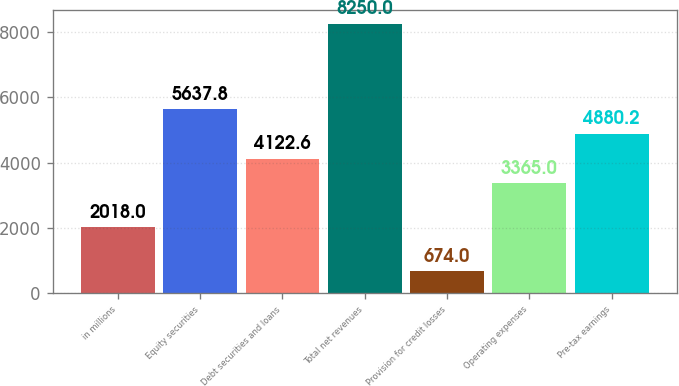Convert chart to OTSL. <chart><loc_0><loc_0><loc_500><loc_500><bar_chart><fcel>in millions<fcel>Equity securities<fcel>Debt securities and loans<fcel>Total net revenues<fcel>Provision for credit losses<fcel>Operating expenses<fcel>Pre-tax earnings<nl><fcel>2018<fcel>5637.8<fcel>4122.6<fcel>8250<fcel>674<fcel>3365<fcel>4880.2<nl></chart> 